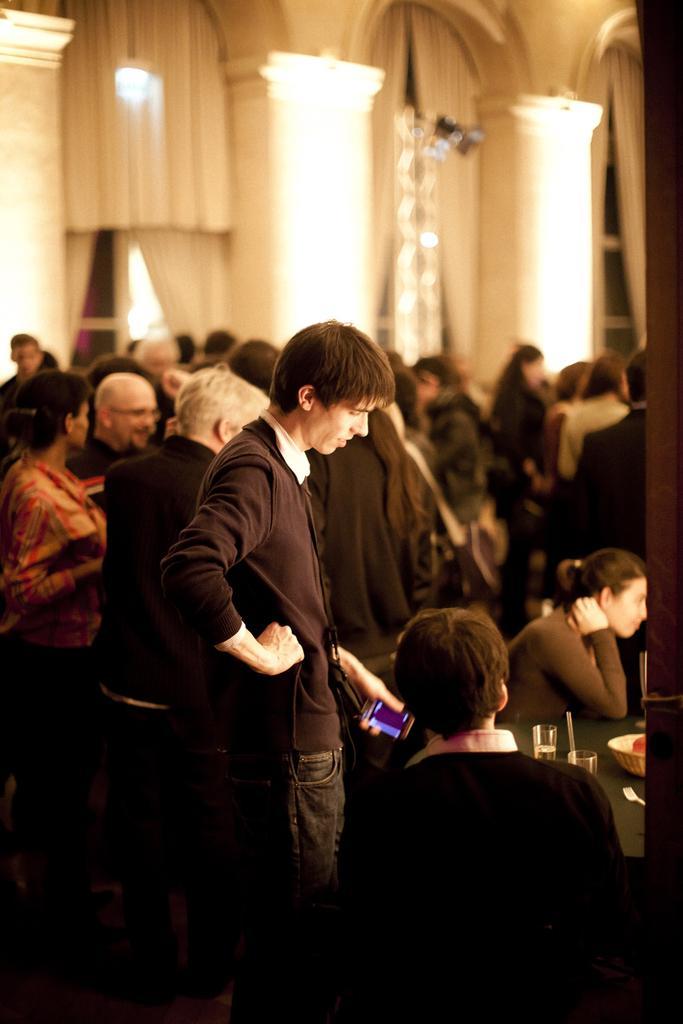In one or two sentences, can you explain what this image depicts? In this picture we can see some people standing, on the right side there are two persons sitting in front of a table, we can see a bowl and two glasses present on the table, in the background there are curtains, this man is holding a mobile phone. 